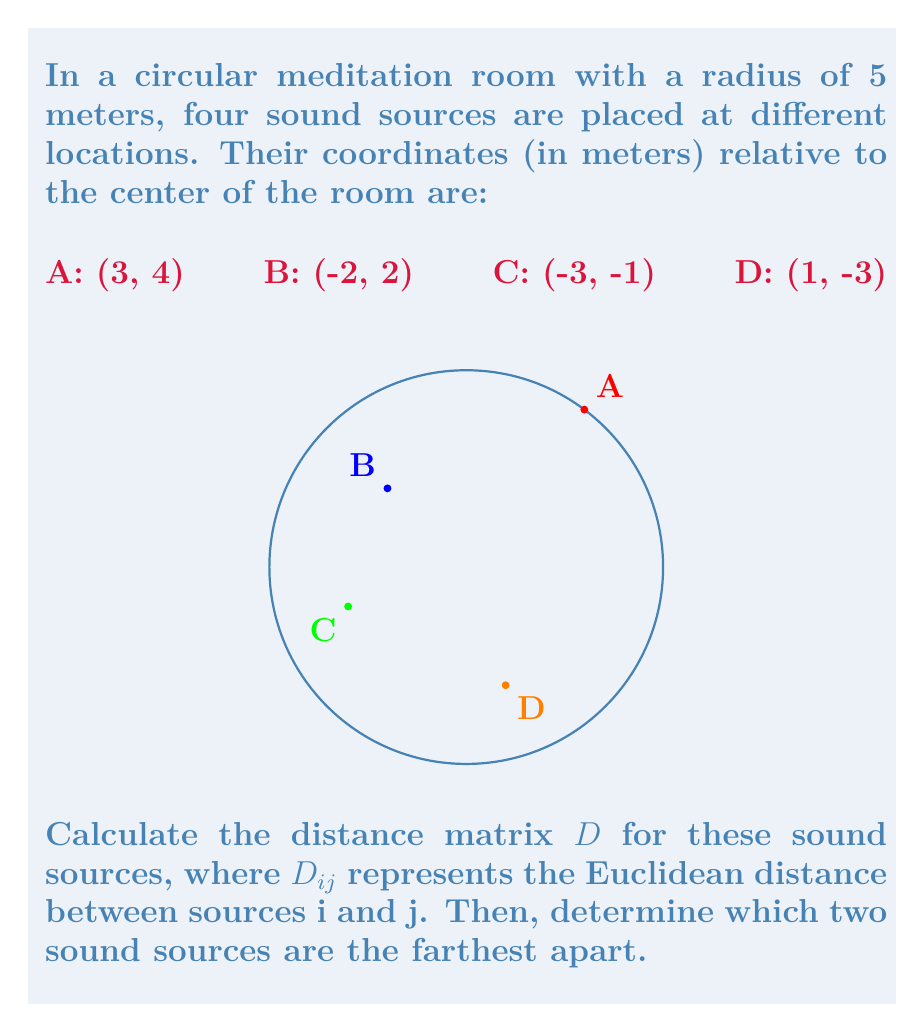Teach me how to tackle this problem. To solve this problem, we'll follow these steps:

1) Calculate the distance between each pair of sound sources using the Euclidean distance formula:

   $d = \sqrt{(x_2-x_1)^2 + (y_2-y_1)^2}$

2) Create the distance matrix $D$.

3) Identify the largest value in the matrix to find the farthest apart sound sources.

Step 1: Calculating distances

AB: $\sqrt{(3-(-2))^2 + (4-2)^2} = \sqrt{5^2 + 2^2} = \sqrt{29}$
AC: $\sqrt{(3-(-3))^2 + (4-(-1))^2} = \sqrt{6^2 + 5^2} = \sqrt{61}$
AD: $\sqrt{(3-1)^2 + (4-(-3))^2} = \sqrt{2^2 + 7^2} = \sqrt{53}$
BC: $\sqrt{(-2-(-3))^2 + (2-(-1))^2} = \sqrt{1^2 + 3^2} = \sqrt{10}$
BD: $\sqrt{(-2-1)^2 + (2-(-3))^2} = \sqrt{(-3)^2 + 5^2} = \sqrt{34}$
CD: $\sqrt{(-3-1)^2 + (-1-(-3))^2} = \sqrt{(-4)^2 + 2^2} = \sqrt{20}$

Step 2: Creating the distance matrix

$$D = \begin{bmatrix}
0 & \sqrt{29} & \sqrt{61} & \sqrt{53} \\
\sqrt{29} & 0 & \sqrt{10} & \sqrt{34} \\
\sqrt{61} & \sqrt{10} & 0 & \sqrt{20} \\
\sqrt{53} & \sqrt{34} & \sqrt{20} & 0
\end{bmatrix}$$

Step 3: Identifying the largest value

The largest value in the matrix is $\sqrt{61}$, which corresponds to the distance between sound sources A and C.
Answer: $D = \begin{bmatrix}
0 & \sqrt{29} & \sqrt{61} & \sqrt{53} \\
\sqrt{29} & 0 & \sqrt{10} & \sqrt{34} \\
\sqrt{61} & \sqrt{10} & 0 & \sqrt{20} \\
\sqrt{53} & \sqrt{34} & \sqrt{20} & 0
\end{bmatrix}$; A and C are farthest apart. 